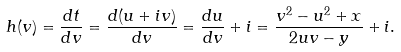Convert formula to latex. <formula><loc_0><loc_0><loc_500><loc_500>h ( v ) = \frac { d t } { d v } = \frac { d ( u + i v ) } { d v } = \frac { d u } { d v } + i = \frac { v ^ { 2 } - u ^ { 2 } + x } { 2 u v - y } + i .</formula> 